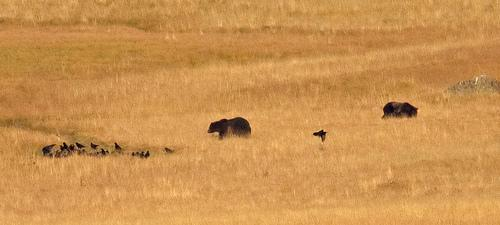Question: where is the picture taken?
Choices:
A. A desert.
B. A forest.
C. A snow slope.
D. A field.
Answer with the letter. Answer: D Question: what animal besides the bears are in the picture?
Choices:
A. Fish.
B. Deer.
C. Racoons.
D. Birds.
Answer with the letter. Answer: D Question: what are the bears doing?
Choices:
A. Eating.
B. Climbing.
C. Running.
D. Walking.
Answer with the letter. Answer: D 